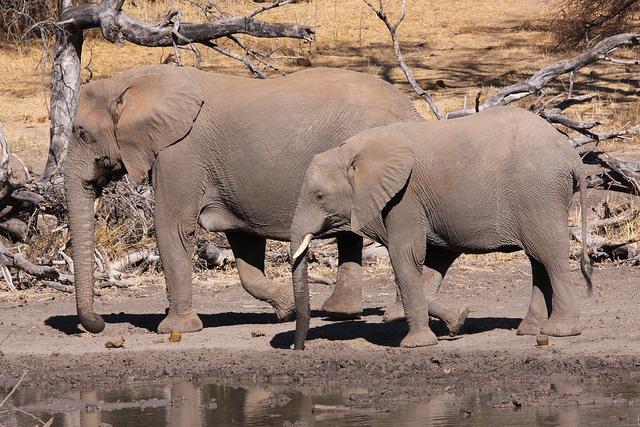Are these creatures purported to have an unusually long memory?
Be succinct. Yes. Does this look like mother and child?
Quick response, please. Yes. Are these animals in the wild?
Answer briefly. Yes. Are the elephants in captivity?
Answer briefly. No. What is on the small elephant's trunk?
Give a very brief answer. Tusk. What is the white projection below the animal's mouth called?
Concise answer only. Tusk. How many animals are here?
Short answer required. 2. Does the baby have hair on its head?
Write a very short answer. No. Are these elephants in the wild?
Be succinct. Yes. Are these animals in their natural habitat?
Be succinct. Yes. 